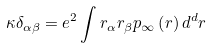<formula> <loc_0><loc_0><loc_500><loc_500>\kappa \delta _ { \alpha \beta } = e ^ { 2 } \int r _ { \alpha } r _ { \beta } p _ { \infty } \left ( r \right ) d ^ { d } r</formula> 